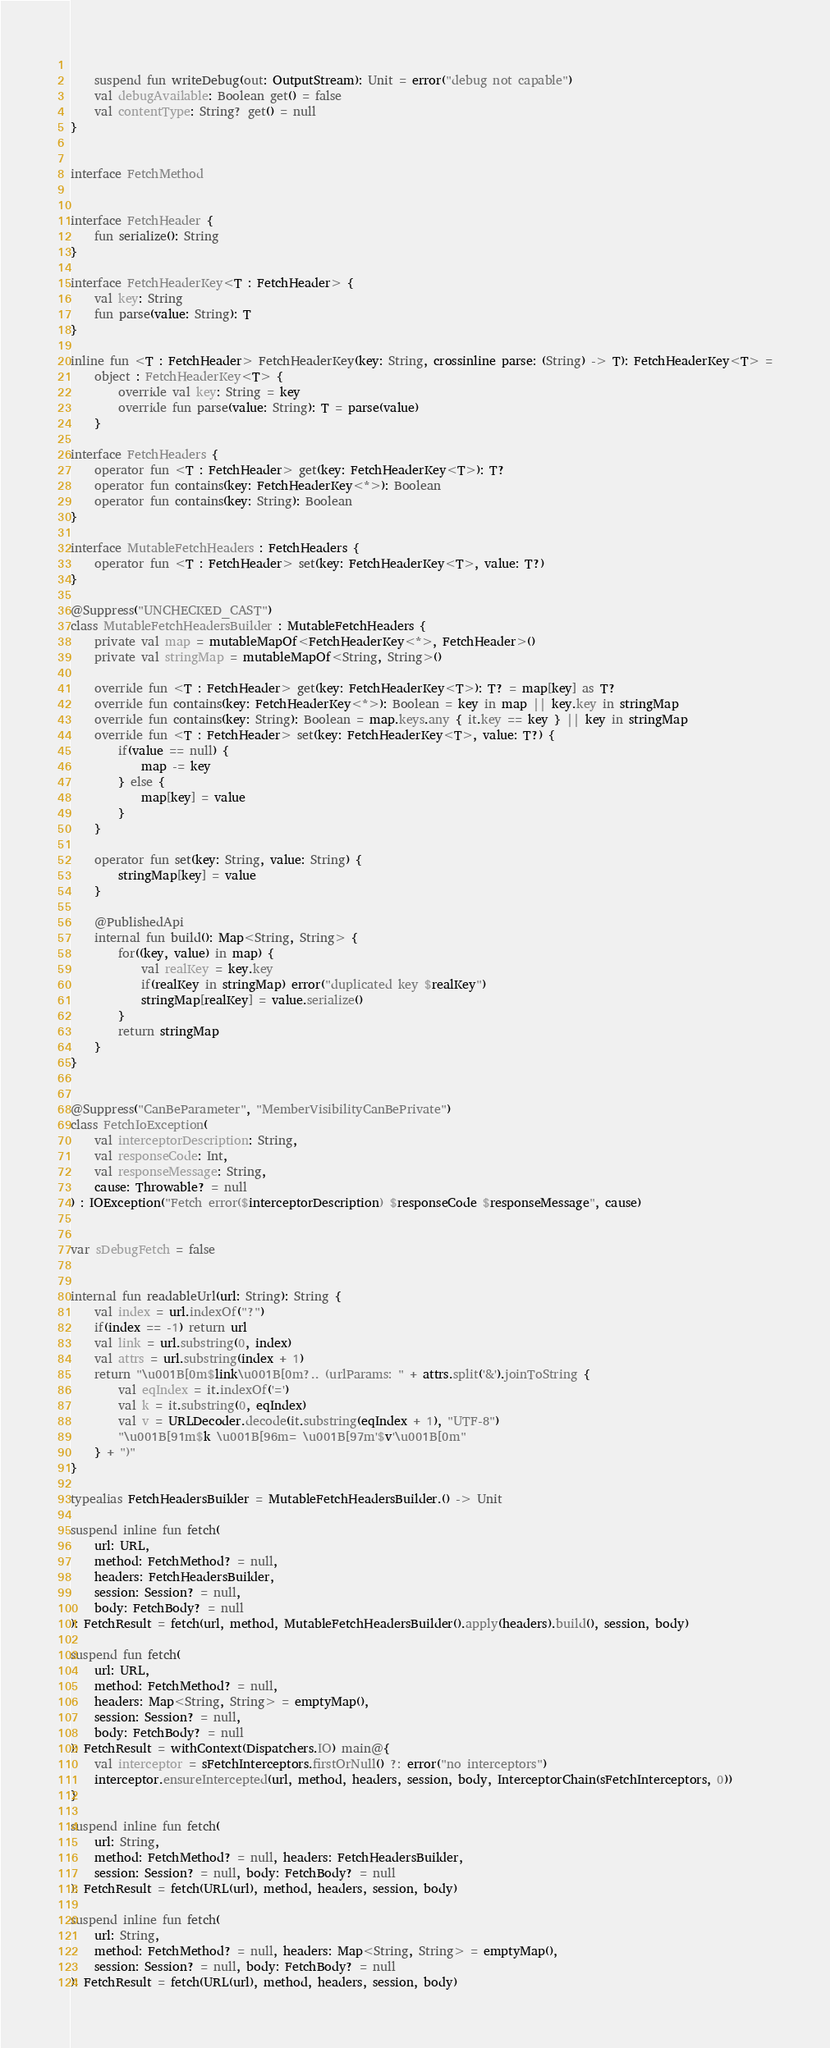Convert code to text. <code><loc_0><loc_0><loc_500><loc_500><_Kotlin_>	
	suspend fun writeDebug(out: OutputStream): Unit = error("debug not capable")
	val debugAvailable: Boolean get() = false
	val contentType: String? get() = null
}


interface FetchMethod


interface FetchHeader {
	fun serialize(): String
}

interface FetchHeaderKey<T : FetchHeader> {
	val key: String
	fun parse(value: String): T
}

inline fun <T : FetchHeader> FetchHeaderKey(key: String, crossinline parse: (String) -> T): FetchHeaderKey<T> =
	object : FetchHeaderKey<T> {
		override val key: String = key
		override fun parse(value: String): T = parse(value)
	}

interface FetchHeaders {
	operator fun <T : FetchHeader> get(key: FetchHeaderKey<T>): T?
	operator fun contains(key: FetchHeaderKey<*>): Boolean
	operator fun contains(key: String): Boolean
}

interface MutableFetchHeaders : FetchHeaders {
	operator fun <T : FetchHeader> set(key: FetchHeaderKey<T>, value: T?)
}

@Suppress("UNCHECKED_CAST")
class MutableFetchHeadersBuilder : MutableFetchHeaders {
	private val map = mutableMapOf<FetchHeaderKey<*>, FetchHeader>()
	private val stringMap = mutableMapOf<String, String>()
	
	override fun <T : FetchHeader> get(key: FetchHeaderKey<T>): T? = map[key] as T?
	override fun contains(key: FetchHeaderKey<*>): Boolean = key in map || key.key in stringMap
	override fun contains(key: String): Boolean = map.keys.any { it.key == key } || key in stringMap
	override fun <T : FetchHeader> set(key: FetchHeaderKey<T>, value: T?) {
		if(value == null) {
			map -= key
		} else {
			map[key] = value
		}
	}
	
	operator fun set(key: String, value: String) {
		stringMap[key] = value
	}
	
	@PublishedApi
	internal fun build(): Map<String, String> {
		for((key, value) in map) {
			val realKey = key.key
			if(realKey in stringMap) error("duplicated key $realKey")
			stringMap[realKey] = value.serialize()
		}
		return stringMap
	}
}


@Suppress("CanBeParameter", "MemberVisibilityCanBePrivate")
class FetchIoException(
	val interceptorDescription: String,
	val responseCode: Int,
	val responseMessage: String,
	cause: Throwable? = null
) : IOException("Fetch error($interceptorDescription) $responseCode $responseMessage", cause)


var sDebugFetch = false


internal fun readableUrl(url: String): String {
	val index = url.indexOf("?")
	if(index == -1) return url
	val link = url.substring(0, index)
	val attrs = url.substring(index + 1)
	return "\u001B[0m$link\u001B[0m?.. (urlParams: " + attrs.split('&').joinToString {
		val eqIndex = it.indexOf('=')
		val k = it.substring(0, eqIndex)
		val v = URLDecoder.decode(it.substring(eqIndex + 1), "UTF-8")
		"\u001B[91m$k \u001B[96m= \u001B[97m'$v'\u001B[0m"
	} + ")"
}

typealias FetchHeadersBuilder = MutableFetchHeadersBuilder.() -> Unit

suspend inline fun fetch(
	url: URL,
	method: FetchMethod? = null,
	headers: FetchHeadersBuilder,
	session: Session? = null,
	body: FetchBody? = null
): FetchResult = fetch(url, method, MutableFetchHeadersBuilder().apply(headers).build(), session, body)

suspend fun fetch(
	url: URL,
	method: FetchMethod? = null,
	headers: Map<String, String> = emptyMap(),
	session: Session? = null,
	body: FetchBody? = null
): FetchResult = withContext(Dispatchers.IO) main@{
	val interceptor = sFetchInterceptors.firstOrNull() ?: error("no interceptors")
	interceptor.ensureIntercepted(url, method, headers, session, body, InterceptorChain(sFetchInterceptors, 0))
}

suspend inline fun fetch(
	url: String,
	method: FetchMethod? = null, headers: FetchHeadersBuilder,
	session: Session? = null, body: FetchBody? = null
): FetchResult = fetch(URL(url), method, headers, session, body)

suspend inline fun fetch(
	url: String,
	method: FetchMethod? = null, headers: Map<String, String> = emptyMap(),
	session: Session? = null, body: FetchBody? = null
): FetchResult = fetch(URL(url), method, headers, session, body)
</code> 